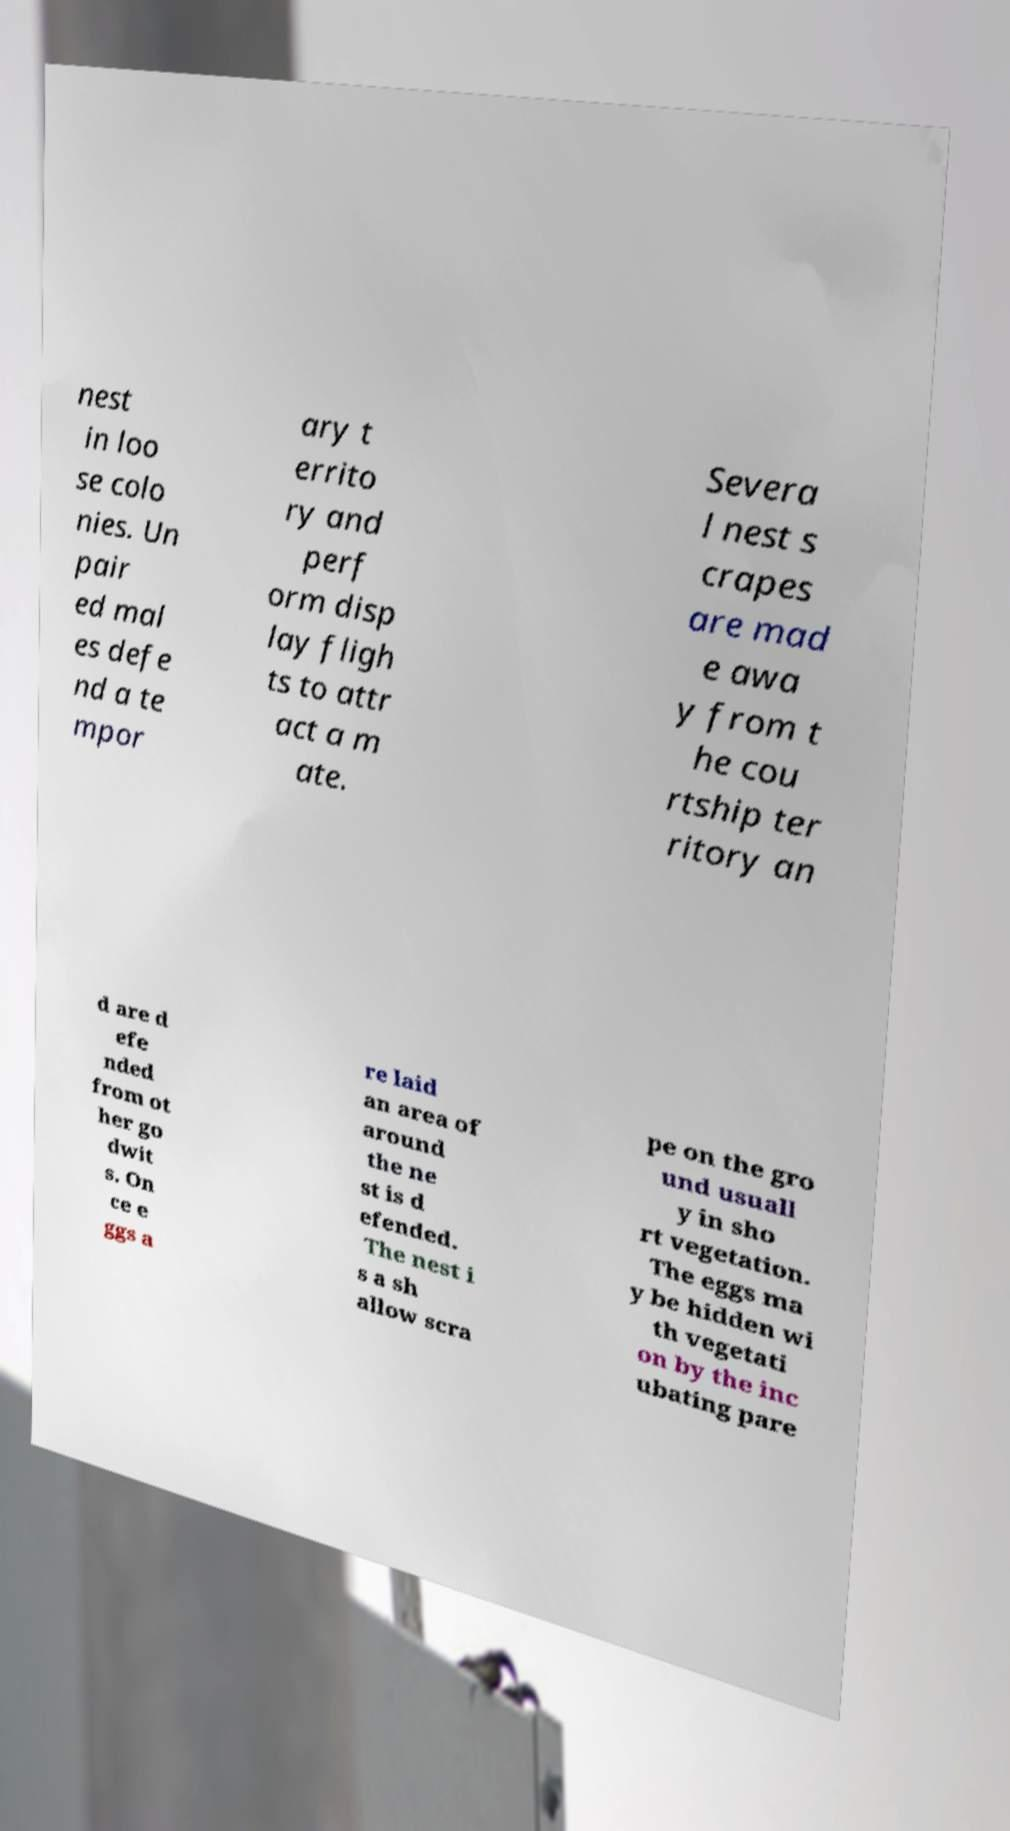Could you extract and type out the text from this image? nest in loo se colo nies. Un pair ed mal es defe nd a te mpor ary t errito ry and perf orm disp lay fligh ts to attr act a m ate. Severa l nest s crapes are mad e awa y from t he cou rtship ter ritory an d are d efe nded from ot her go dwit s. On ce e ggs a re laid an area of around the ne st is d efended. The nest i s a sh allow scra pe on the gro und usuall y in sho rt vegetation. The eggs ma y be hidden wi th vegetati on by the inc ubating pare 